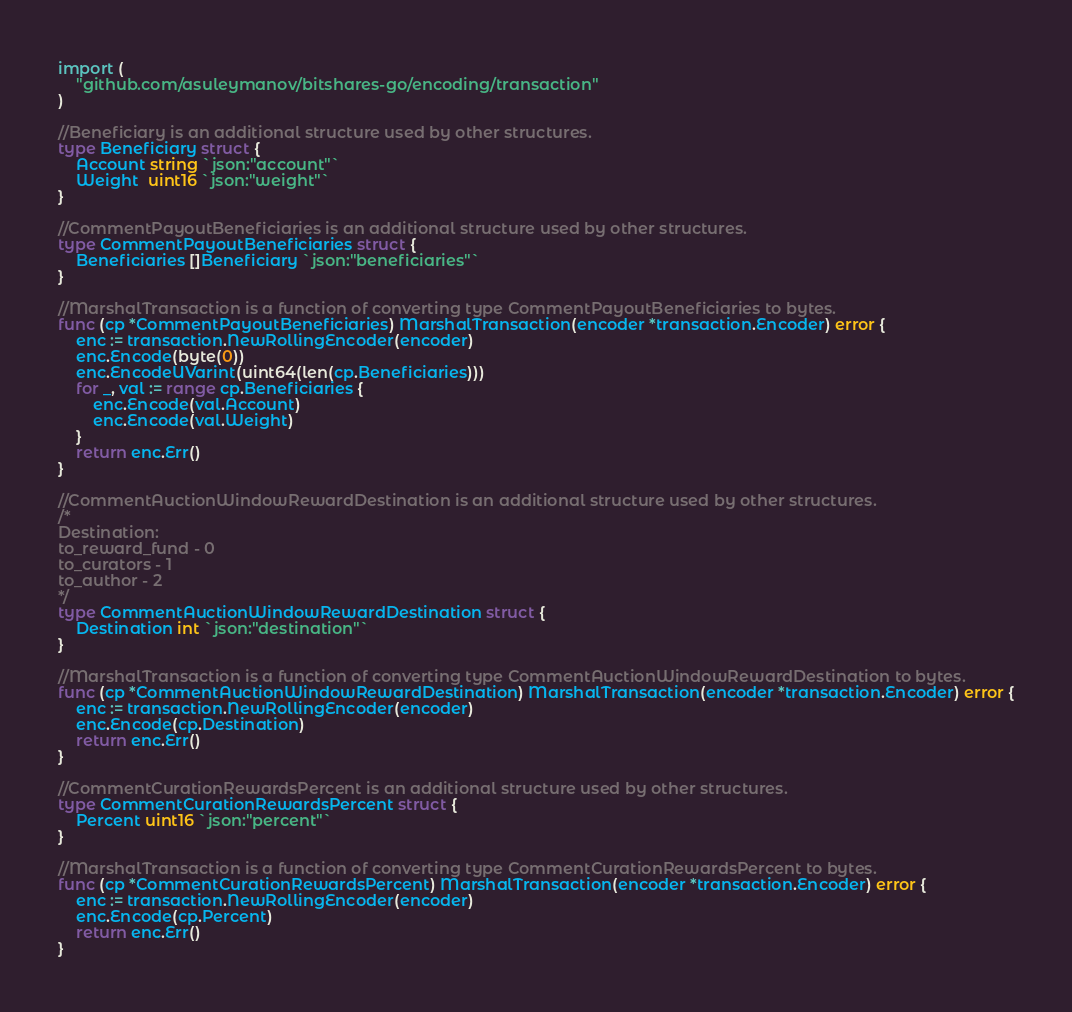<code> <loc_0><loc_0><loc_500><loc_500><_Go_>
import (
	"github.com/asuleymanov/bitshares-go/encoding/transaction"
)

//Beneficiary is an additional structure used by other structures.
type Beneficiary struct {
	Account string `json:"account"`
	Weight  uint16 `json:"weight"`
}

//CommentPayoutBeneficiaries is an additional structure used by other structures.
type CommentPayoutBeneficiaries struct {
	Beneficiaries []Beneficiary `json:"beneficiaries"`
}

//MarshalTransaction is a function of converting type CommentPayoutBeneficiaries to bytes.
func (cp *CommentPayoutBeneficiaries) MarshalTransaction(encoder *transaction.Encoder) error {
	enc := transaction.NewRollingEncoder(encoder)
	enc.Encode(byte(0))
	enc.EncodeUVarint(uint64(len(cp.Beneficiaries)))
	for _, val := range cp.Beneficiaries {
		enc.Encode(val.Account)
		enc.Encode(val.Weight)
	}
	return enc.Err()
}

//CommentAuctionWindowRewardDestination is an additional structure used by other structures.
/*
Destination:
to_reward_fund - 0
to_curators - 1
to_author - 2
*/
type CommentAuctionWindowRewardDestination struct {
	Destination int `json:"destination"`
}

//MarshalTransaction is a function of converting type CommentAuctionWindowRewardDestination to bytes.
func (cp *CommentAuctionWindowRewardDestination) MarshalTransaction(encoder *transaction.Encoder) error {
	enc := transaction.NewRollingEncoder(encoder)
	enc.Encode(cp.Destination)
	return enc.Err()
}

//CommentCurationRewardsPercent is an additional structure used by other structures.
type CommentCurationRewardsPercent struct {
	Percent uint16 `json:"percent"`
}

//MarshalTransaction is a function of converting type CommentCurationRewardsPercent to bytes.
func (cp *CommentCurationRewardsPercent) MarshalTransaction(encoder *transaction.Encoder) error {
	enc := transaction.NewRollingEncoder(encoder)
	enc.Encode(cp.Percent)
	return enc.Err()
}
</code> 